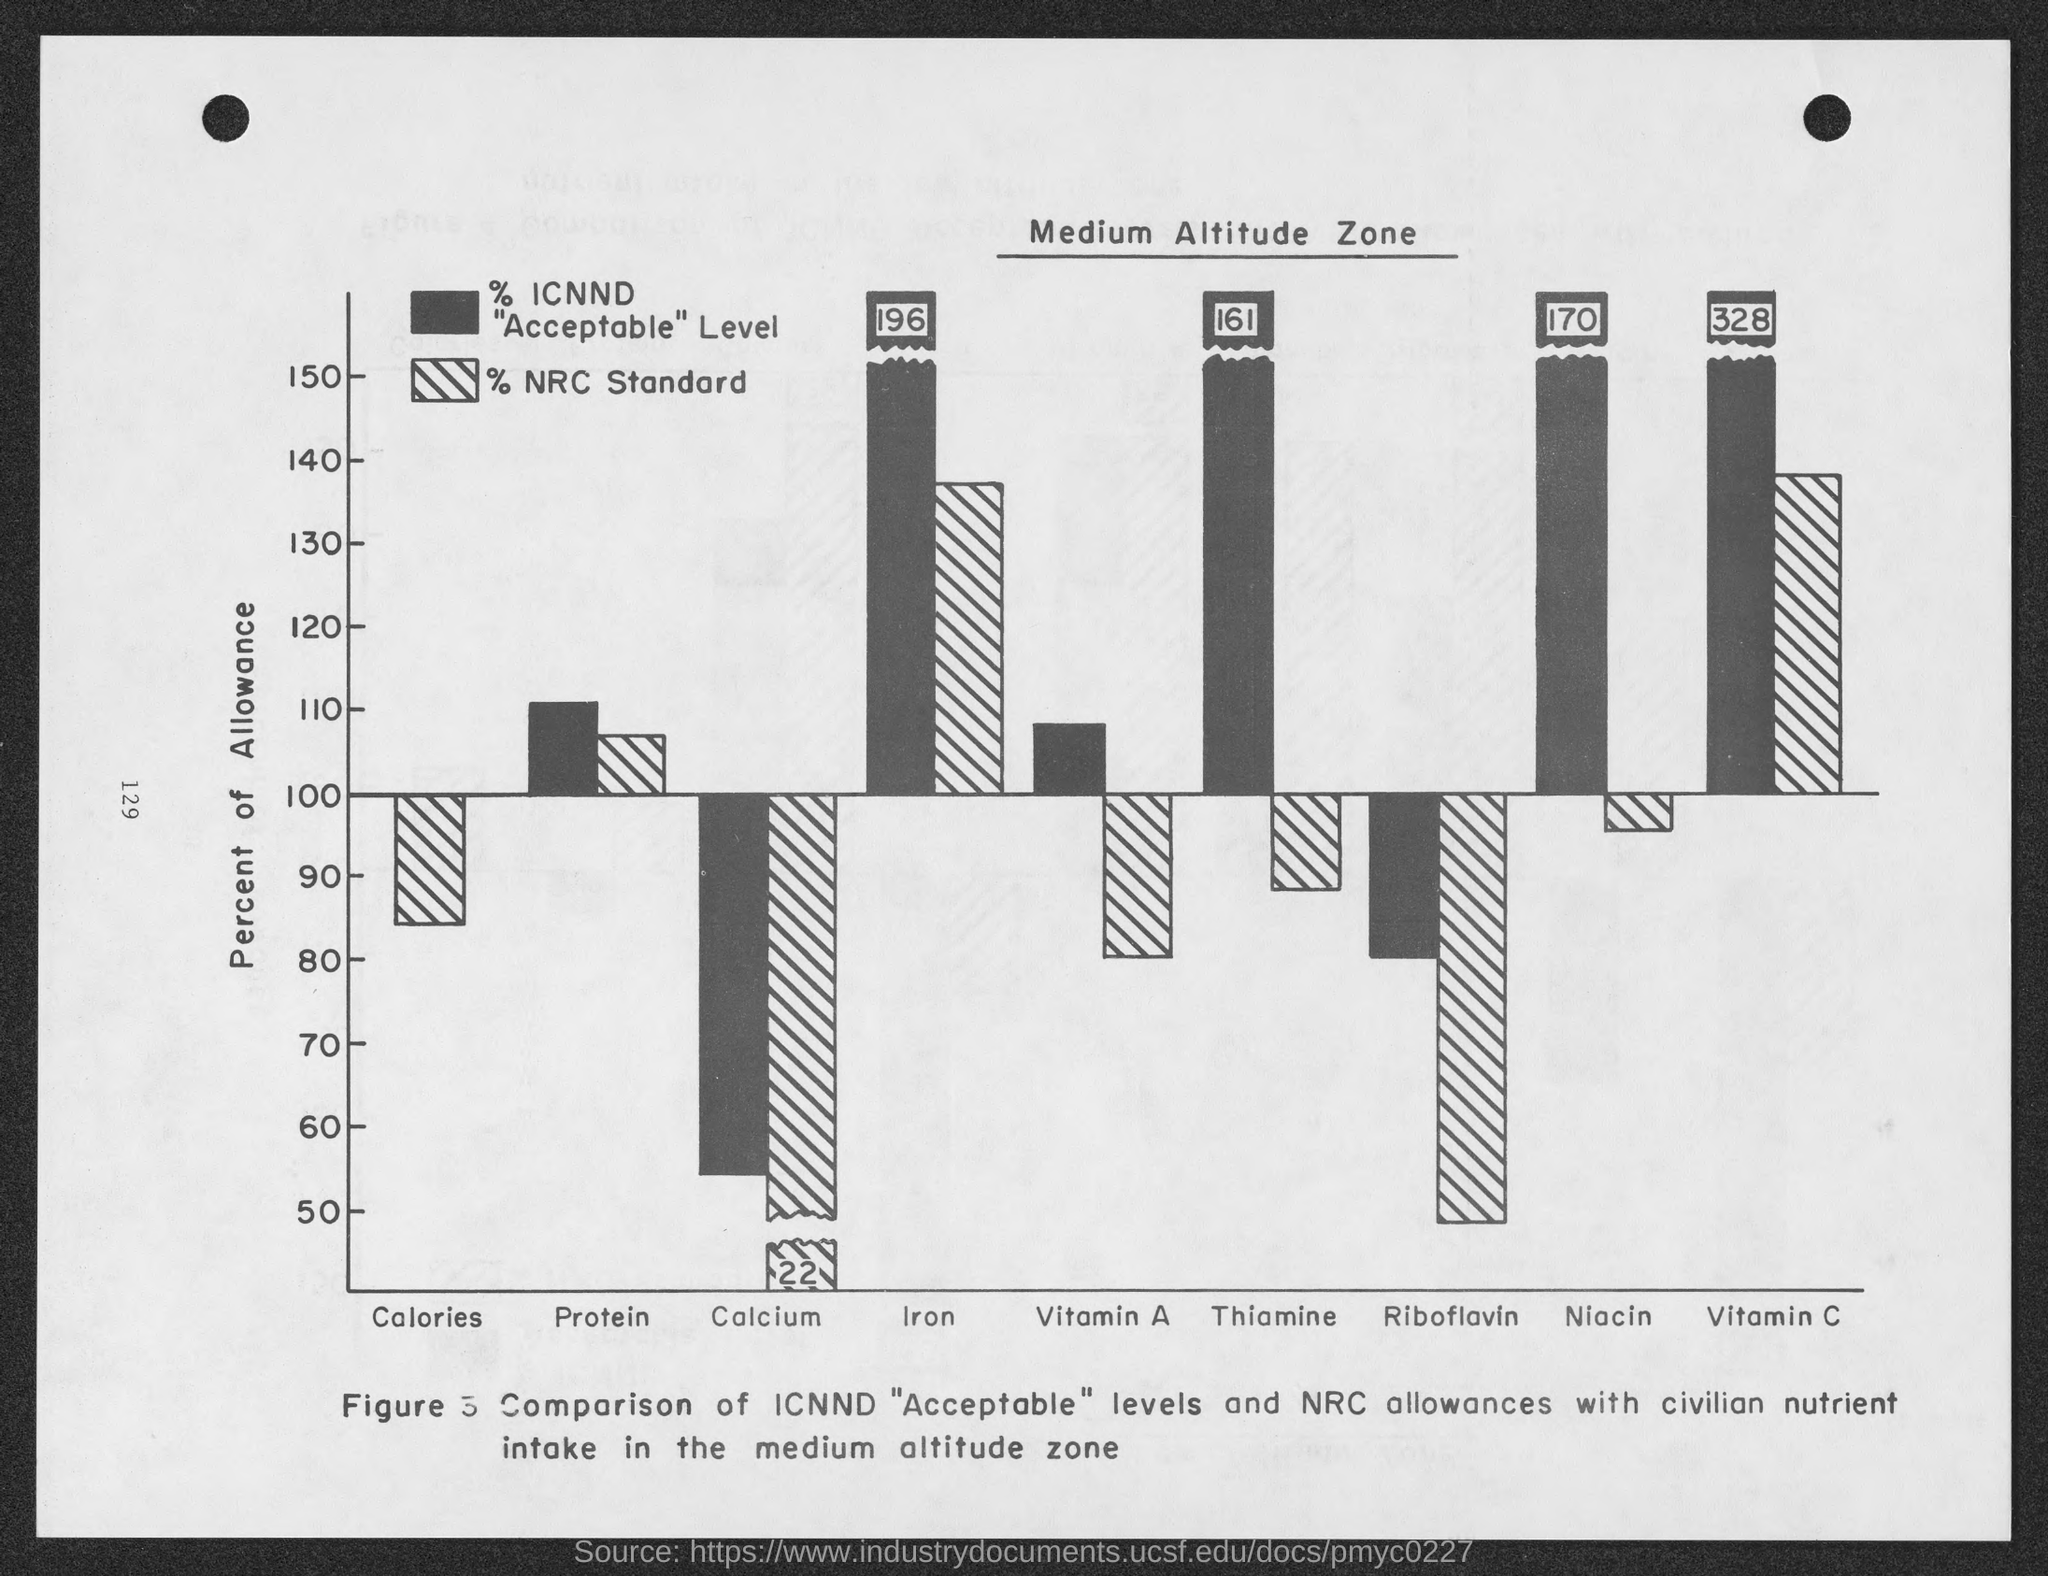In the graph, what does the Y axis represent?
Offer a terse response. Percent of Allowance. What is the highest value on the Y axis?
Your answer should be compact. 150. What is the first variable on the X axis?
Offer a terse response. Calories. What is the last variable on the X axis?
Keep it short and to the point. Vitamin C. What is the tile of the page?
Your response must be concise. Medium Altitude Zone. 